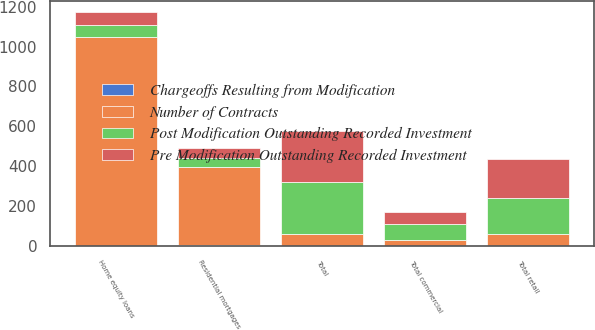<chart> <loc_0><loc_0><loc_500><loc_500><stacked_bar_chart><ecel><fcel>Total commercial<fcel>Residential mortgages<fcel>Home equity loans<fcel>Total retail<fcel>Total<nl><fcel>Number of Contracts<fcel>28<fcel>393<fcel>1046<fcel>60.5<fcel>60.5<nl><fcel>Pre Modification Outstanding Recorded Investment<fcel>59<fcel>47<fcel>63<fcel>192<fcel>251<nl><fcel>Post Modification Outstanding Recorded Investment<fcel>81<fcel>46<fcel>62<fcel>181<fcel>262<nl><fcel>Chargeoffs Resulting from Modification<fcel>3<fcel>4<fcel>1<fcel>2<fcel>1<nl></chart> 